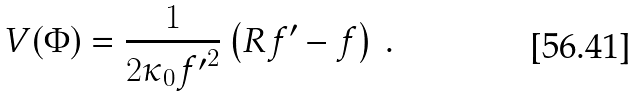Convert formula to latex. <formula><loc_0><loc_0><loc_500><loc_500>V ( \Phi ) = \frac { 1 } { 2 \kappa _ { 0 } { f ^ { \prime } } ^ { 2 } } \left ( R f ^ { \prime } - f \right ) \, .</formula> 